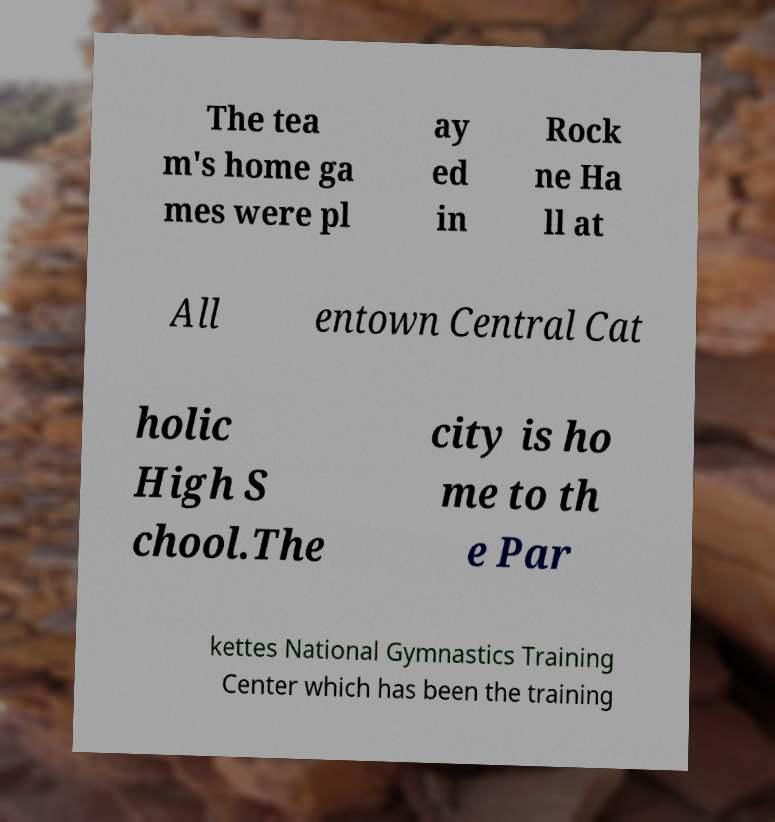I need the written content from this picture converted into text. Can you do that? The tea m's home ga mes were pl ay ed in Rock ne Ha ll at All entown Central Cat holic High S chool.The city is ho me to th e Par kettes National Gymnastics Training Center which has been the training 